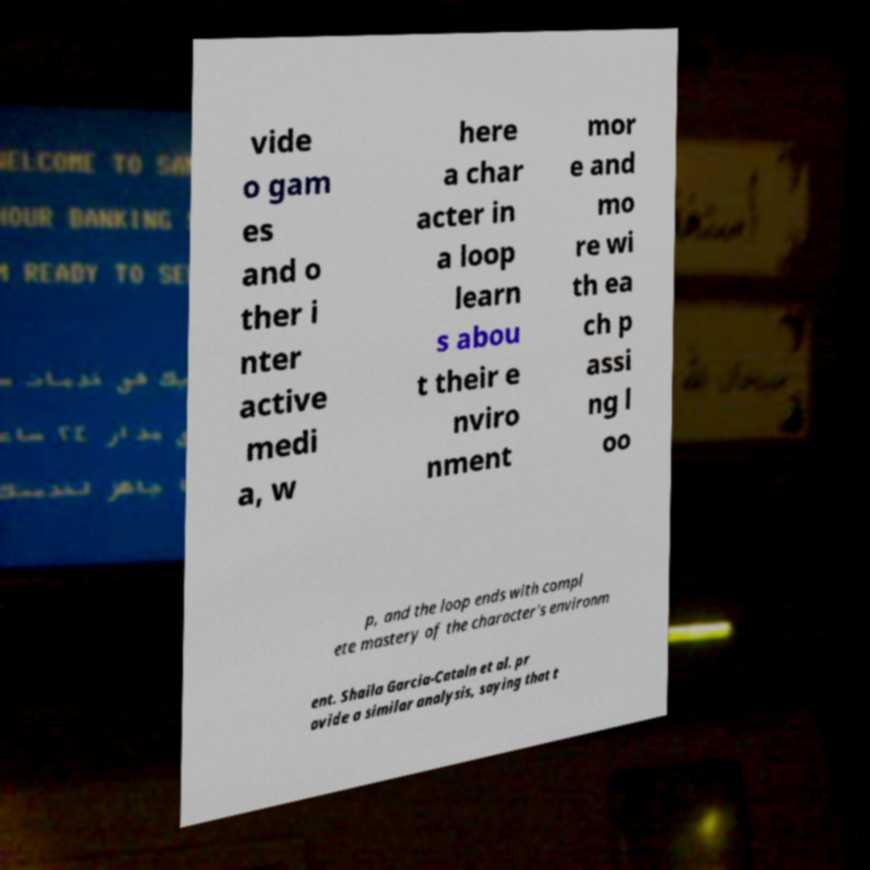Can you accurately transcribe the text from the provided image for me? vide o gam es and o ther i nter active medi a, w here a char acter in a loop learn s abou t their e nviro nment mor e and mo re wi th ea ch p assi ng l oo p, and the loop ends with compl ete mastery of the character's environm ent. Shaila Garcia-Cataln et al. pr ovide a similar analysis, saying that t 